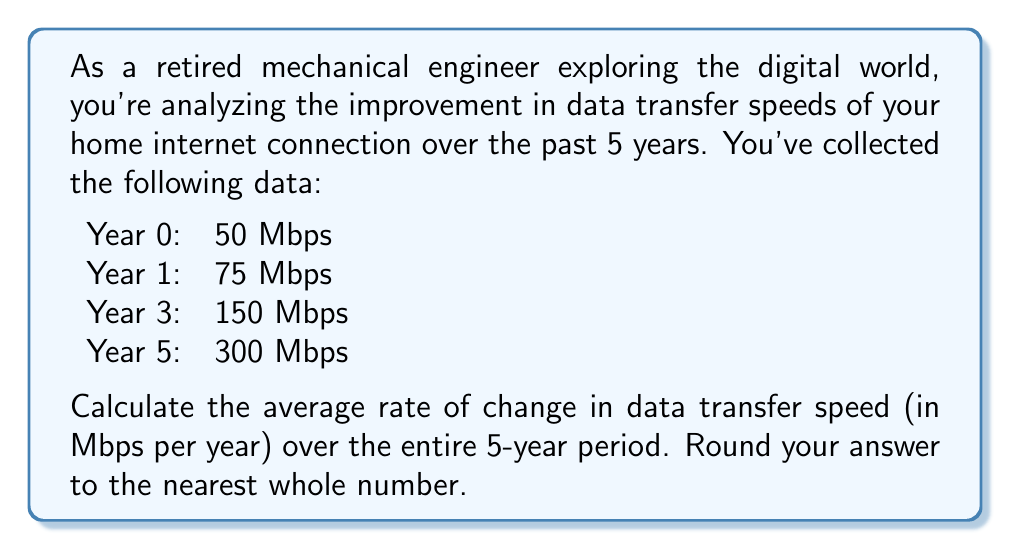Teach me how to tackle this problem. To solve this problem, we'll use the average rate of change formula:

$$ \text{Average rate of change} = \frac{\text{Change in y}}{\text{Change in x}} = \frac{\Delta y}{\Delta x} $$

In this case:
- $\Delta y$ is the change in data transfer speed (Mbps)
- $\Delta x$ is the change in time (years)

Let's calculate:

1. Find $\Delta y$:
   Final speed - Initial speed = 300 Mbps - 50 Mbps = 250 Mbps

2. Find $\Delta x$:
   Total time period = 5 years

3. Apply the formula:
   $$ \text{Average rate of change} = \frac{250 \text{ Mbps}}{5 \text{ years}} = 50 \text{ Mbps/year} $$

4. The question asks to round to the nearest whole number, but 50 is already a whole number, so no rounding is necessary.

This means that, on average, the data transfer speed increased by 50 Mbps each year over the 5-year period.
Answer: 50 Mbps/year 